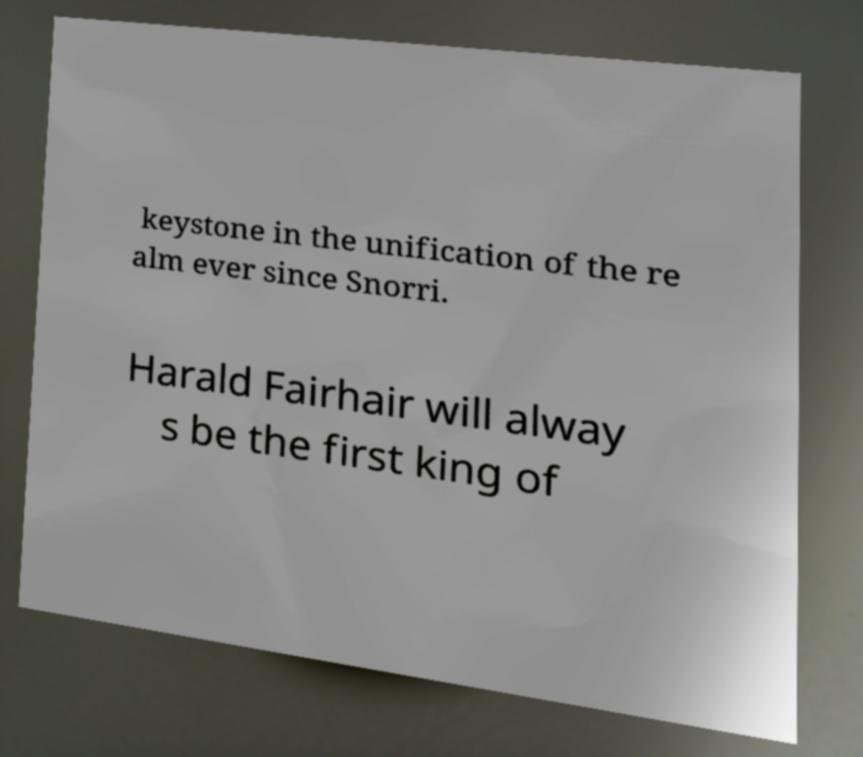For documentation purposes, I need the text within this image transcribed. Could you provide that? keystone in the unification of the re alm ever since Snorri. Harald Fairhair will alway s be the first king of 